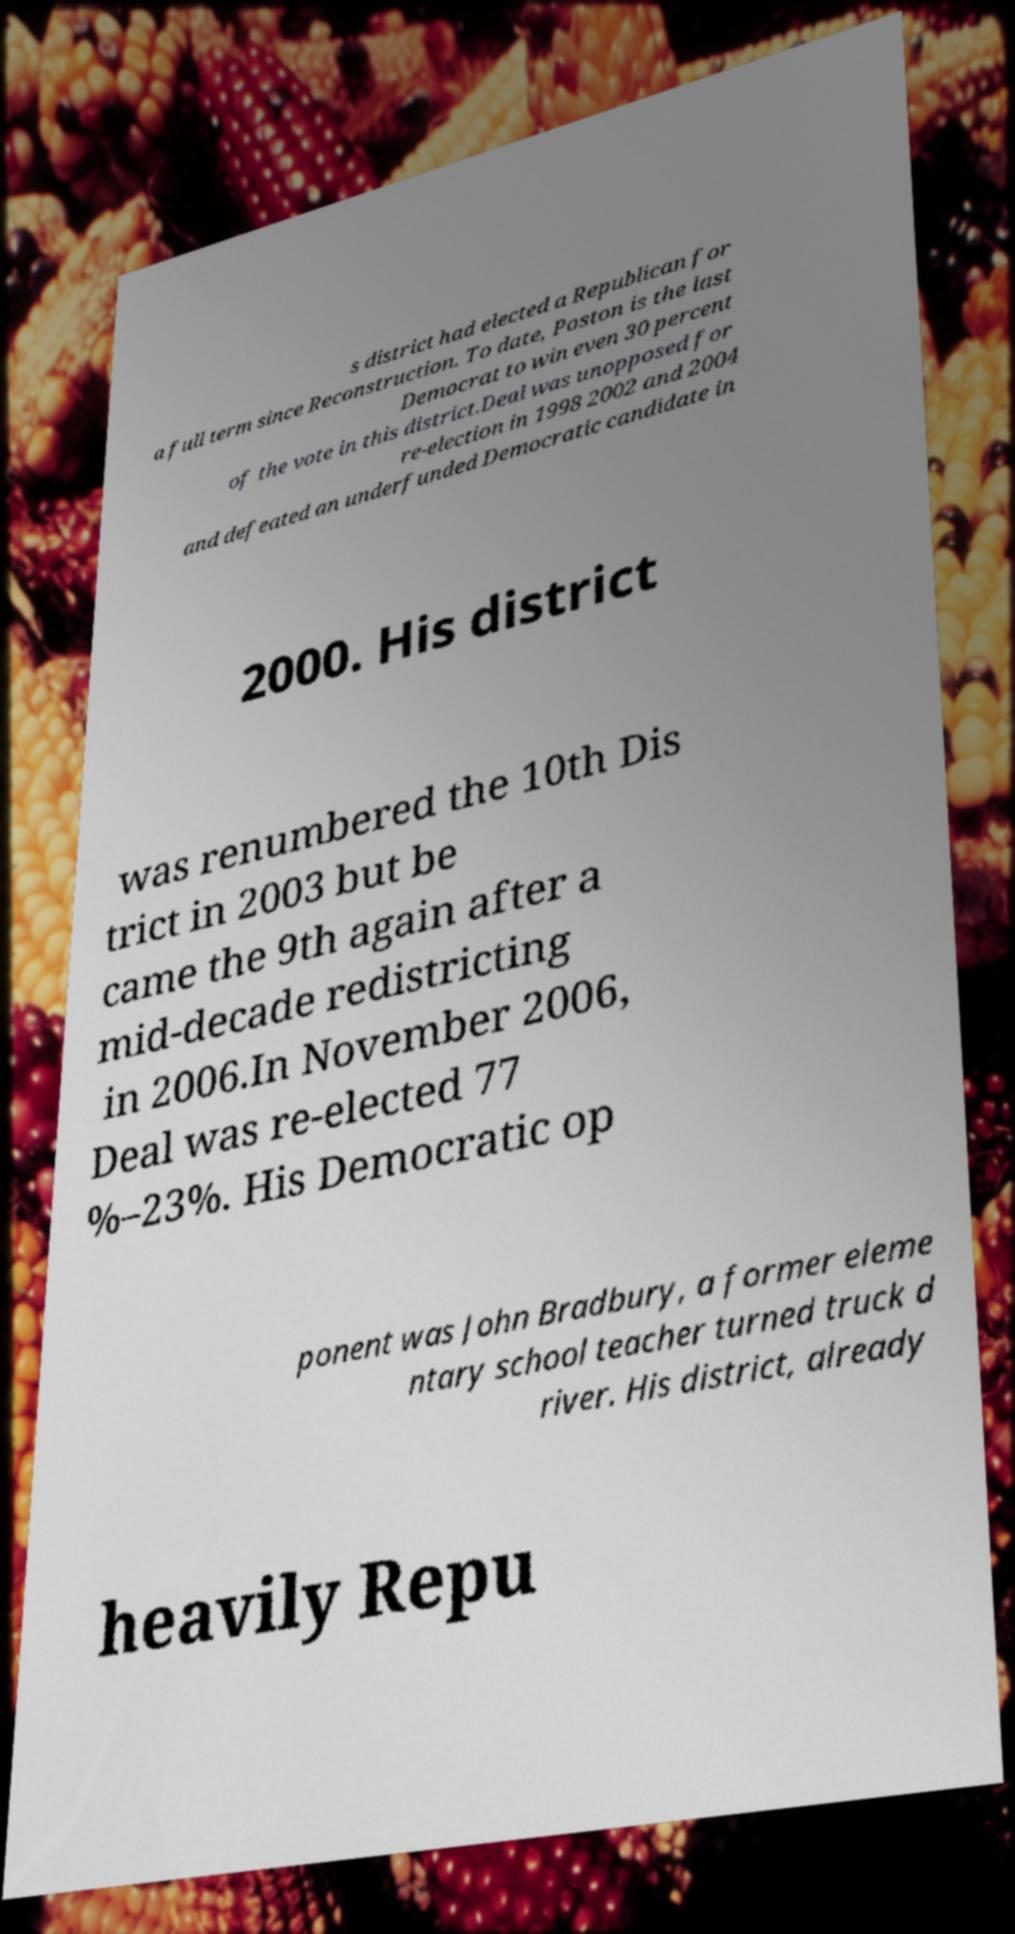Can you accurately transcribe the text from the provided image for me? s district had elected a Republican for a full term since Reconstruction. To date, Poston is the last Democrat to win even 30 percent of the vote in this district.Deal was unopposed for re-election in 1998 2002 and 2004 and defeated an underfunded Democratic candidate in 2000. His district was renumbered the 10th Dis trict in 2003 but be came the 9th again after a mid-decade redistricting in 2006.In November 2006, Deal was re-elected 77 %–23%. His Democratic op ponent was John Bradbury, a former eleme ntary school teacher turned truck d river. His district, already heavily Repu 